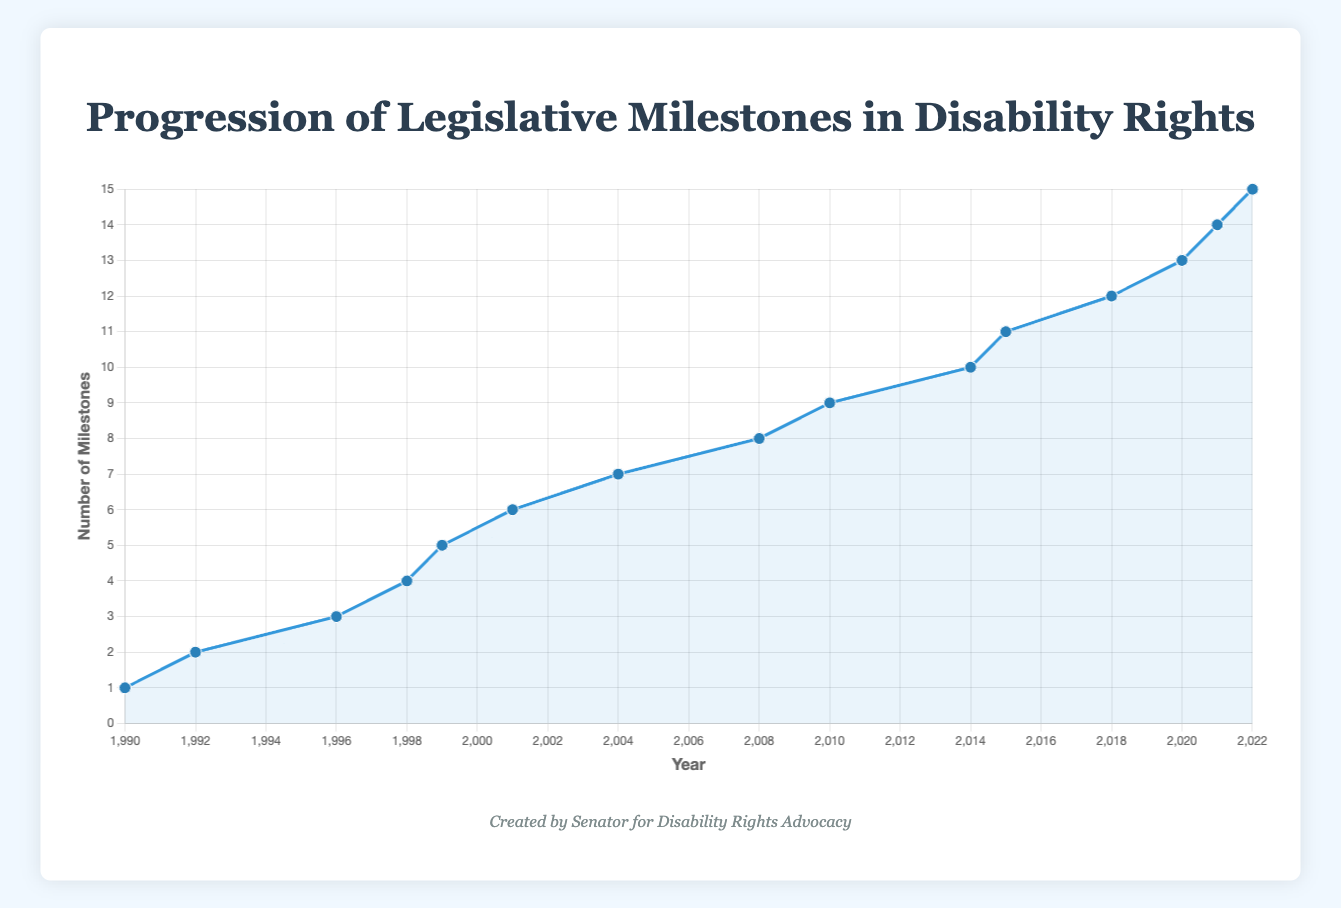What year had the highest number of legislative milestones recorded? The line plot only goes up, meaning the latest year always has the highest cumulative number of milestones. By observing the plot, the highest number of milestones is recorded in 2022.
Answer: 2022 Which milestone occurred in 2001? By looking at the line plot and the tooltip labels, the milestone in 2001 is "New Freedom Initiative Launched."
Answer: New Freedom Initiative Launched Between 1990 and 2015, during which period did the most milestones occur? Counting the milestones from the plot between 1990 and 2015: 1990 (1), 1992 (2), 1996 (3), 1998 (4), 1999 (5), 2001 (6), 2004 (7), 2008 (8), 2010 (9), 2014 (10), 2015 (11), the number of milestones increases linearly. The highest frequency during a period within 1990 to 2015 is between 2008 to 2015 (7 milestones).
Answer: 2008-2015 By how many milestones did the count increase from 1999 to 2004? In 1999, the milestone count is 5, and in 2004, it is 7. The increase is 7 - 5 = 2 milestones.
Answer: 2 Are there any periods with no new legislative milestones? If so, what are they? By looking at the line plot, periods where the line is flat indicate no new milestones. The periods are from 1992 to 1996 and 2015 to 2018.
Answer: 1992-1996, 2015-2018 What is the milestone for the year 1990? Using the tooltip from the line plot, the milestone for 1990 is "Americans with Disabilities Act (ADA) Enacted."
Answer: Americans with Disabilities Act (ADA) Enacted How many milestones were recorded by the year 1998? Observing from the line plot, the number of milestones by 1998 is 4.
Answer: 4 What is the label of the first milestone recorded after 2010? By looking at the line plot for the first point after 2010, it's in 2014 marked as "Workforce Innovation and Opportunity Act (WIOA)."
Answer: Workforce Innovation and Opportunity Act (WIOA) How many years are there between the first and last milestones on the plot? The first milestone is in 1990, and the last milestone is in 2022. The difference is 2022 - 1990 = 32 years.
Answer: 32 Compare and identify the period with the highest rate of increase in milestones. From the line plot, the steepest slopes represent the highest rates of increase. The most rapid increase is from 2008 to 2015, with an increase of 4 milestones in 7 years.
Answer: 2008-2015 